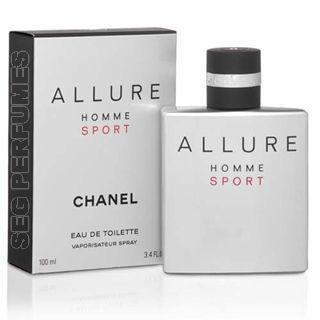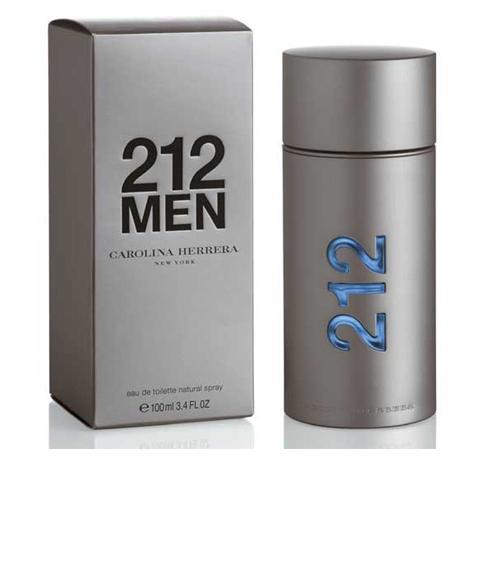The first image is the image on the left, the second image is the image on the right. Given the left and right images, does the statement "There is a total of 1 black box." hold true? Answer yes or no. No. The first image is the image on the left, the second image is the image on the right. Examine the images to the left and right. Is the description "There is a cologne bottle displaying the number 212 on its side." accurate? Answer yes or no. Yes. 